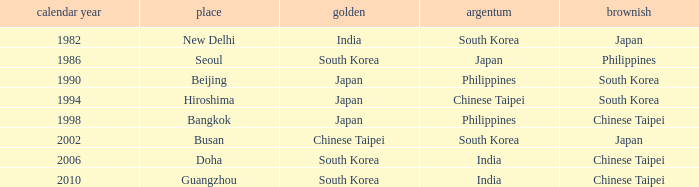Which Year is the highest one that has a Bronze of south korea, and a Silver of philippines? 1990.0. 